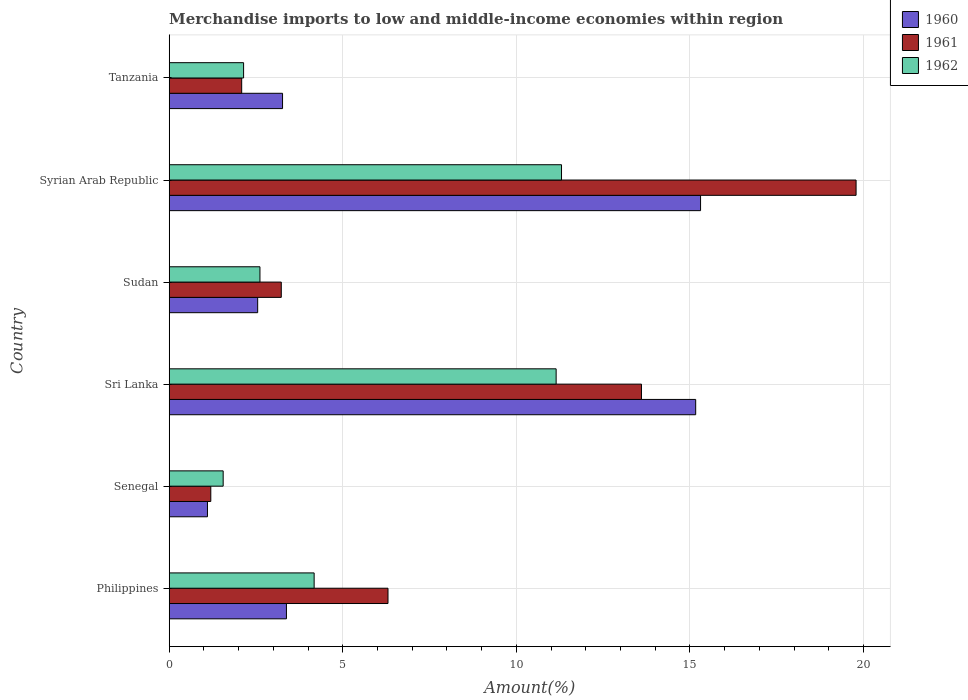Are the number of bars per tick equal to the number of legend labels?
Your answer should be very brief. Yes. What is the label of the 1st group of bars from the top?
Ensure brevity in your answer.  Tanzania. What is the percentage of amount earned from merchandise imports in 1962 in Syrian Arab Republic?
Your answer should be very brief. 11.3. Across all countries, what is the maximum percentage of amount earned from merchandise imports in 1961?
Offer a terse response. 19.79. Across all countries, what is the minimum percentage of amount earned from merchandise imports in 1962?
Give a very brief answer. 1.55. In which country was the percentage of amount earned from merchandise imports in 1960 maximum?
Your response must be concise. Syrian Arab Republic. In which country was the percentage of amount earned from merchandise imports in 1962 minimum?
Offer a very short reply. Senegal. What is the total percentage of amount earned from merchandise imports in 1960 in the graph?
Provide a succinct answer. 40.77. What is the difference between the percentage of amount earned from merchandise imports in 1960 in Philippines and that in Senegal?
Your answer should be compact. 2.28. What is the difference between the percentage of amount earned from merchandise imports in 1960 in Sudan and the percentage of amount earned from merchandise imports in 1962 in Tanzania?
Ensure brevity in your answer.  0.41. What is the average percentage of amount earned from merchandise imports in 1960 per country?
Offer a very short reply. 6.79. What is the difference between the percentage of amount earned from merchandise imports in 1962 and percentage of amount earned from merchandise imports in 1961 in Sri Lanka?
Offer a terse response. -2.46. What is the ratio of the percentage of amount earned from merchandise imports in 1961 in Sudan to that in Tanzania?
Your response must be concise. 1.55. Is the percentage of amount earned from merchandise imports in 1962 in Philippines less than that in Senegal?
Offer a very short reply. No. What is the difference between the highest and the second highest percentage of amount earned from merchandise imports in 1962?
Your answer should be very brief. 0.16. What is the difference between the highest and the lowest percentage of amount earned from merchandise imports in 1962?
Provide a short and direct response. 9.75. Is the sum of the percentage of amount earned from merchandise imports in 1962 in Senegal and Sudan greater than the maximum percentage of amount earned from merchandise imports in 1961 across all countries?
Your answer should be compact. No. How many bars are there?
Give a very brief answer. 18. Are all the bars in the graph horizontal?
Offer a terse response. Yes. Does the graph contain any zero values?
Give a very brief answer. No. What is the title of the graph?
Your answer should be compact. Merchandise imports to low and middle-income economies within region. Does "1985" appear as one of the legend labels in the graph?
Ensure brevity in your answer.  No. What is the label or title of the X-axis?
Keep it short and to the point. Amount(%). What is the Amount(%) of 1960 in Philippines?
Your answer should be compact. 3.38. What is the Amount(%) of 1961 in Philippines?
Ensure brevity in your answer.  6.3. What is the Amount(%) in 1962 in Philippines?
Provide a succinct answer. 4.18. What is the Amount(%) in 1960 in Senegal?
Your answer should be very brief. 1.1. What is the Amount(%) of 1961 in Senegal?
Your answer should be compact. 1.2. What is the Amount(%) in 1962 in Senegal?
Your answer should be compact. 1.55. What is the Amount(%) in 1960 in Sri Lanka?
Give a very brief answer. 15.17. What is the Amount(%) of 1961 in Sri Lanka?
Keep it short and to the point. 13.6. What is the Amount(%) of 1962 in Sri Lanka?
Provide a short and direct response. 11.15. What is the Amount(%) in 1960 in Sudan?
Keep it short and to the point. 2.55. What is the Amount(%) of 1961 in Sudan?
Make the answer very short. 3.23. What is the Amount(%) in 1962 in Sudan?
Provide a succinct answer. 2.61. What is the Amount(%) of 1960 in Syrian Arab Republic?
Keep it short and to the point. 15.31. What is the Amount(%) in 1961 in Syrian Arab Republic?
Offer a very short reply. 19.79. What is the Amount(%) in 1962 in Syrian Arab Republic?
Ensure brevity in your answer.  11.3. What is the Amount(%) in 1960 in Tanzania?
Offer a very short reply. 3.26. What is the Amount(%) in 1961 in Tanzania?
Your answer should be very brief. 2.09. What is the Amount(%) in 1962 in Tanzania?
Your answer should be compact. 2.14. Across all countries, what is the maximum Amount(%) in 1960?
Provide a short and direct response. 15.31. Across all countries, what is the maximum Amount(%) of 1961?
Your answer should be compact. 19.79. Across all countries, what is the maximum Amount(%) of 1962?
Your answer should be very brief. 11.3. Across all countries, what is the minimum Amount(%) of 1960?
Give a very brief answer. 1.1. Across all countries, what is the minimum Amount(%) in 1961?
Your answer should be very brief. 1.2. Across all countries, what is the minimum Amount(%) of 1962?
Your answer should be very brief. 1.55. What is the total Amount(%) of 1960 in the graph?
Offer a terse response. 40.77. What is the total Amount(%) of 1961 in the graph?
Give a very brief answer. 46.21. What is the total Amount(%) in 1962 in the graph?
Keep it short and to the point. 32.93. What is the difference between the Amount(%) in 1960 in Philippines and that in Senegal?
Give a very brief answer. 2.28. What is the difference between the Amount(%) in 1961 in Philippines and that in Senegal?
Your response must be concise. 5.1. What is the difference between the Amount(%) in 1962 in Philippines and that in Senegal?
Offer a very short reply. 2.62. What is the difference between the Amount(%) of 1960 in Philippines and that in Sri Lanka?
Your response must be concise. -11.79. What is the difference between the Amount(%) of 1961 in Philippines and that in Sri Lanka?
Make the answer very short. -7.3. What is the difference between the Amount(%) of 1962 in Philippines and that in Sri Lanka?
Provide a succinct answer. -6.97. What is the difference between the Amount(%) in 1960 in Philippines and that in Sudan?
Ensure brevity in your answer.  0.83. What is the difference between the Amount(%) of 1961 in Philippines and that in Sudan?
Offer a terse response. 3.07. What is the difference between the Amount(%) in 1962 in Philippines and that in Sudan?
Keep it short and to the point. 1.56. What is the difference between the Amount(%) in 1960 in Philippines and that in Syrian Arab Republic?
Offer a very short reply. -11.93. What is the difference between the Amount(%) of 1961 in Philippines and that in Syrian Arab Republic?
Your response must be concise. -13.48. What is the difference between the Amount(%) in 1962 in Philippines and that in Syrian Arab Republic?
Make the answer very short. -7.13. What is the difference between the Amount(%) in 1960 in Philippines and that in Tanzania?
Make the answer very short. 0.11. What is the difference between the Amount(%) in 1961 in Philippines and that in Tanzania?
Provide a short and direct response. 4.21. What is the difference between the Amount(%) in 1962 in Philippines and that in Tanzania?
Offer a terse response. 2.03. What is the difference between the Amount(%) in 1960 in Senegal and that in Sri Lanka?
Your response must be concise. -14.06. What is the difference between the Amount(%) in 1961 in Senegal and that in Sri Lanka?
Give a very brief answer. -12.41. What is the difference between the Amount(%) in 1962 in Senegal and that in Sri Lanka?
Provide a succinct answer. -9.59. What is the difference between the Amount(%) in 1960 in Senegal and that in Sudan?
Give a very brief answer. -1.45. What is the difference between the Amount(%) in 1961 in Senegal and that in Sudan?
Keep it short and to the point. -2.03. What is the difference between the Amount(%) of 1962 in Senegal and that in Sudan?
Provide a short and direct response. -1.06. What is the difference between the Amount(%) of 1960 in Senegal and that in Syrian Arab Republic?
Ensure brevity in your answer.  -14.2. What is the difference between the Amount(%) of 1961 in Senegal and that in Syrian Arab Republic?
Your response must be concise. -18.59. What is the difference between the Amount(%) in 1962 in Senegal and that in Syrian Arab Republic?
Make the answer very short. -9.75. What is the difference between the Amount(%) in 1960 in Senegal and that in Tanzania?
Offer a very short reply. -2.16. What is the difference between the Amount(%) of 1961 in Senegal and that in Tanzania?
Offer a very short reply. -0.89. What is the difference between the Amount(%) of 1962 in Senegal and that in Tanzania?
Your answer should be very brief. -0.59. What is the difference between the Amount(%) of 1960 in Sri Lanka and that in Sudan?
Your answer should be compact. 12.62. What is the difference between the Amount(%) of 1961 in Sri Lanka and that in Sudan?
Provide a short and direct response. 10.38. What is the difference between the Amount(%) in 1962 in Sri Lanka and that in Sudan?
Your answer should be compact. 8.53. What is the difference between the Amount(%) in 1960 in Sri Lanka and that in Syrian Arab Republic?
Provide a short and direct response. -0.14. What is the difference between the Amount(%) in 1961 in Sri Lanka and that in Syrian Arab Republic?
Provide a succinct answer. -6.18. What is the difference between the Amount(%) in 1962 in Sri Lanka and that in Syrian Arab Republic?
Offer a very short reply. -0.16. What is the difference between the Amount(%) of 1960 in Sri Lanka and that in Tanzania?
Provide a succinct answer. 11.9. What is the difference between the Amount(%) of 1961 in Sri Lanka and that in Tanzania?
Provide a short and direct response. 11.52. What is the difference between the Amount(%) in 1962 in Sri Lanka and that in Tanzania?
Keep it short and to the point. 9. What is the difference between the Amount(%) of 1960 in Sudan and that in Syrian Arab Republic?
Provide a short and direct response. -12.76. What is the difference between the Amount(%) of 1961 in Sudan and that in Syrian Arab Republic?
Your answer should be compact. -16.56. What is the difference between the Amount(%) in 1962 in Sudan and that in Syrian Arab Republic?
Keep it short and to the point. -8.69. What is the difference between the Amount(%) in 1960 in Sudan and that in Tanzania?
Ensure brevity in your answer.  -0.72. What is the difference between the Amount(%) in 1961 in Sudan and that in Tanzania?
Offer a very short reply. 1.14. What is the difference between the Amount(%) of 1962 in Sudan and that in Tanzania?
Keep it short and to the point. 0.47. What is the difference between the Amount(%) of 1960 in Syrian Arab Republic and that in Tanzania?
Ensure brevity in your answer.  12.04. What is the difference between the Amount(%) in 1961 in Syrian Arab Republic and that in Tanzania?
Ensure brevity in your answer.  17.7. What is the difference between the Amount(%) in 1962 in Syrian Arab Republic and that in Tanzania?
Ensure brevity in your answer.  9.16. What is the difference between the Amount(%) in 1960 in Philippines and the Amount(%) in 1961 in Senegal?
Keep it short and to the point. 2.18. What is the difference between the Amount(%) of 1960 in Philippines and the Amount(%) of 1962 in Senegal?
Provide a short and direct response. 1.82. What is the difference between the Amount(%) of 1961 in Philippines and the Amount(%) of 1962 in Senegal?
Your response must be concise. 4.75. What is the difference between the Amount(%) in 1960 in Philippines and the Amount(%) in 1961 in Sri Lanka?
Offer a very short reply. -10.23. What is the difference between the Amount(%) in 1960 in Philippines and the Amount(%) in 1962 in Sri Lanka?
Offer a very short reply. -7.77. What is the difference between the Amount(%) of 1961 in Philippines and the Amount(%) of 1962 in Sri Lanka?
Your response must be concise. -4.84. What is the difference between the Amount(%) of 1960 in Philippines and the Amount(%) of 1961 in Sudan?
Offer a terse response. 0.15. What is the difference between the Amount(%) in 1960 in Philippines and the Amount(%) in 1962 in Sudan?
Your answer should be very brief. 0.76. What is the difference between the Amount(%) of 1961 in Philippines and the Amount(%) of 1962 in Sudan?
Ensure brevity in your answer.  3.69. What is the difference between the Amount(%) of 1960 in Philippines and the Amount(%) of 1961 in Syrian Arab Republic?
Keep it short and to the point. -16.41. What is the difference between the Amount(%) of 1960 in Philippines and the Amount(%) of 1962 in Syrian Arab Republic?
Your answer should be very brief. -7.92. What is the difference between the Amount(%) in 1961 in Philippines and the Amount(%) in 1962 in Syrian Arab Republic?
Provide a short and direct response. -5. What is the difference between the Amount(%) in 1960 in Philippines and the Amount(%) in 1961 in Tanzania?
Offer a very short reply. 1.29. What is the difference between the Amount(%) in 1960 in Philippines and the Amount(%) in 1962 in Tanzania?
Your answer should be very brief. 1.23. What is the difference between the Amount(%) in 1961 in Philippines and the Amount(%) in 1962 in Tanzania?
Your answer should be compact. 4.16. What is the difference between the Amount(%) of 1960 in Senegal and the Amount(%) of 1961 in Sri Lanka?
Ensure brevity in your answer.  -12.5. What is the difference between the Amount(%) in 1960 in Senegal and the Amount(%) in 1962 in Sri Lanka?
Your answer should be compact. -10.04. What is the difference between the Amount(%) of 1961 in Senegal and the Amount(%) of 1962 in Sri Lanka?
Provide a succinct answer. -9.95. What is the difference between the Amount(%) of 1960 in Senegal and the Amount(%) of 1961 in Sudan?
Your answer should be very brief. -2.13. What is the difference between the Amount(%) in 1960 in Senegal and the Amount(%) in 1962 in Sudan?
Offer a terse response. -1.51. What is the difference between the Amount(%) in 1961 in Senegal and the Amount(%) in 1962 in Sudan?
Your answer should be compact. -1.42. What is the difference between the Amount(%) in 1960 in Senegal and the Amount(%) in 1961 in Syrian Arab Republic?
Provide a succinct answer. -18.68. What is the difference between the Amount(%) in 1960 in Senegal and the Amount(%) in 1962 in Syrian Arab Republic?
Provide a succinct answer. -10.2. What is the difference between the Amount(%) in 1961 in Senegal and the Amount(%) in 1962 in Syrian Arab Republic?
Your response must be concise. -10.1. What is the difference between the Amount(%) of 1960 in Senegal and the Amount(%) of 1961 in Tanzania?
Your answer should be compact. -0.99. What is the difference between the Amount(%) in 1960 in Senegal and the Amount(%) in 1962 in Tanzania?
Ensure brevity in your answer.  -1.04. What is the difference between the Amount(%) of 1961 in Senegal and the Amount(%) of 1962 in Tanzania?
Your answer should be very brief. -0.94. What is the difference between the Amount(%) in 1960 in Sri Lanka and the Amount(%) in 1961 in Sudan?
Your answer should be very brief. 11.94. What is the difference between the Amount(%) in 1960 in Sri Lanka and the Amount(%) in 1962 in Sudan?
Your response must be concise. 12.55. What is the difference between the Amount(%) in 1961 in Sri Lanka and the Amount(%) in 1962 in Sudan?
Ensure brevity in your answer.  10.99. What is the difference between the Amount(%) in 1960 in Sri Lanka and the Amount(%) in 1961 in Syrian Arab Republic?
Give a very brief answer. -4.62. What is the difference between the Amount(%) in 1960 in Sri Lanka and the Amount(%) in 1962 in Syrian Arab Republic?
Offer a terse response. 3.87. What is the difference between the Amount(%) in 1961 in Sri Lanka and the Amount(%) in 1962 in Syrian Arab Republic?
Keep it short and to the point. 2.3. What is the difference between the Amount(%) in 1960 in Sri Lanka and the Amount(%) in 1961 in Tanzania?
Provide a short and direct response. 13.08. What is the difference between the Amount(%) in 1960 in Sri Lanka and the Amount(%) in 1962 in Tanzania?
Your response must be concise. 13.02. What is the difference between the Amount(%) of 1961 in Sri Lanka and the Amount(%) of 1962 in Tanzania?
Your answer should be very brief. 11.46. What is the difference between the Amount(%) of 1960 in Sudan and the Amount(%) of 1961 in Syrian Arab Republic?
Your answer should be compact. -17.24. What is the difference between the Amount(%) of 1960 in Sudan and the Amount(%) of 1962 in Syrian Arab Republic?
Offer a very short reply. -8.75. What is the difference between the Amount(%) in 1961 in Sudan and the Amount(%) in 1962 in Syrian Arab Republic?
Your response must be concise. -8.07. What is the difference between the Amount(%) of 1960 in Sudan and the Amount(%) of 1961 in Tanzania?
Provide a succinct answer. 0.46. What is the difference between the Amount(%) in 1960 in Sudan and the Amount(%) in 1962 in Tanzania?
Keep it short and to the point. 0.41. What is the difference between the Amount(%) of 1961 in Sudan and the Amount(%) of 1962 in Tanzania?
Give a very brief answer. 1.09. What is the difference between the Amount(%) of 1960 in Syrian Arab Republic and the Amount(%) of 1961 in Tanzania?
Offer a very short reply. 13.22. What is the difference between the Amount(%) of 1960 in Syrian Arab Republic and the Amount(%) of 1962 in Tanzania?
Ensure brevity in your answer.  13.16. What is the difference between the Amount(%) in 1961 in Syrian Arab Republic and the Amount(%) in 1962 in Tanzania?
Provide a succinct answer. 17.64. What is the average Amount(%) of 1960 per country?
Offer a terse response. 6.79. What is the average Amount(%) of 1961 per country?
Your answer should be compact. 7.7. What is the average Amount(%) of 1962 per country?
Your answer should be compact. 5.49. What is the difference between the Amount(%) of 1960 and Amount(%) of 1961 in Philippines?
Provide a short and direct response. -2.93. What is the difference between the Amount(%) in 1960 and Amount(%) in 1962 in Philippines?
Offer a terse response. -0.8. What is the difference between the Amount(%) of 1961 and Amount(%) of 1962 in Philippines?
Make the answer very short. 2.13. What is the difference between the Amount(%) of 1960 and Amount(%) of 1961 in Senegal?
Your answer should be very brief. -0.1. What is the difference between the Amount(%) of 1960 and Amount(%) of 1962 in Senegal?
Your response must be concise. -0.45. What is the difference between the Amount(%) in 1961 and Amount(%) in 1962 in Senegal?
Your answer should be very brief. -0.36. What is the difference between the Amount(%) of 1960 and Amount(%) of 1961 in Sri Lanka?
Offer a terse response. 1.56. What is the difference between the Amount(%) in 1960 and Amount(%) in 1962 in Sri Lanka?
Provide a short and direct response. 4.02. What is the difference between the Amount(%) of 1961 and Amount(%) of 1962 in Sri Lanka?
Your answer should be very brief. 2.46. What is the difference between the Amount(%) of 1960 and Amount(%) of 1961 in Sudan?
Ensure brevity in your answer.  -0.68. What is the difference between the Amount(%) of 1960 and Amount(%) of 1962 in Sudan?
Your response must be concise. -0.07. What is the difference between the Amount(%) in 1961 and Amount(%) in 1962 in Sudan?
Ensure brevity in your answer.  0.61. What is the difference between the Amount(%) in 1960 and Amount(%) in 1961 in Syrian Arab Republic?
Your answer should be very brief. -4.48. What is the difference between the Amount(%) of 1960 and Amount(%) of 1962 in Syrian Arab Republic?
Your answer should be compact. 4.01. What is the difference between the Amount(%) in 1961 and Amount(%) in 1962 in Syrian Arab Republic?
Ensure brevity in your answer.  8.49. What is the difference between the Amount(%) of 1960 and Amount(%) of 1961 in Tanzania?
Keep it short and to the point. 1.18. What is the difference between the Amount(%) in 1960 and Amount(%) in 1962 in Tanzania?
Provide a succinct answer. 1.12. What is the difference between the Amount(%) of 1961 and Amount(%) of 1962 in Tanzania?
Your response must be concise. -0.05. What is the ratio of the Amount(%) of 1960 in Philippines to that in Senegal?
Offer a terse response. 3.06. What is the ratio of the Amount(%) in 1961 in Philippines to that in Senegal?
Your response must be concise. 5.26. What is the ratio of the Amount(%) of 1962 in Philippines to that in Senegal?
Offer a terse response. 2.69. What is the ratio of the Amount(%) in 1960 in Philippines to that in Sri Lanka?
Keep it short and to the point. 0.22. What is the ratio of the Amount(%) in 1961 in Philippines to that in Sri Lanka?
Make the answer very short. 0.46. What is the ratio of the Amount(%) in 1962 in Philippines to that in Sri Lanka?
Give a very brief answer. 0.37. What is the ratio of the Amount(%) of 1960 in Philippines to that in Sudan?
Ensure brevity in your answer.  1.33. What is the ratio of the Amount(%) in 1961 in Philippines to that in Sudan?
Your answer should be very brief. 1.95. What is the ratio of the Amount(%) in 1962 in Philippines to that in Sudan?
Give a very brief answer. 1.6. What is the ratio of the Amount(%) in 1960 in Philippines to that in Syrian Arab Republic?
Offer a very short reply. 0.22. What is the ratio of the Amount(%) in 1961 in Philippines to that in Syrian Arab Republic?
Ensure brevity in your answer.  0.32. What is the ratio of the Amount(%) of 1962 in Philippines to that in Syrian Arab Republic?
Your answer should be very brief. 0.37. What is the ratio of the Amount(%) in 1960 in Philippines to that in Tanzania?
Provide a succinct answer. 1.03. What is the ratio of the Amount(%) in 1961 in Philippines to that in Tanzania?
Give a very brief answer. 3.02. What is the ratio of the Amount(%) of 1962 in Philippines to that in Tanzania?
Offer a terse response. 1.95. What is the ratio of the Amount(%) of 1960 in Senegal to that in Sri Lanka?
Ensure brevity in your answer.  0.07. What is the ratio of the Amount(%) of 1961 in Senegal to that in Sri Lanka?
Keep it short and to the point. 0.09. What is the ratio of the Amount(%) in 1962 in Senegal to that in Sri Lanka?
Your answer should be very brief. 0.14. What is the ratio of the Amount(%) of 1960 in Senegal to that in Sudan?
Ensure brevity in your answer.  0.43. What is the ratio of the Amount(%) of 1961 in Senegal to that in Sudan?
Offer a terse response. 0.37. What is the ratio of the Amount(%) of 1962 in Senegal to that in Sudan?
Your response must be concise. 0.59. What is the ratio of the Amount(%) in 1960 in Senegal to that in Syrian Arab Republic?
Your response must be concise. 0.07. What is the ratio of the Amount(%) in 1961 in Senegal to that in Syrian Arab Republic?
Your answer should be compact. 0.06. What is the ratio of the Amount(%) of 1962 in Senegal to that in Syrian Arab Republic?
Make the answer very short. 0.14. What is the ratio of the Amount(%) of 1960 in Senegal to that in Tanzania?
Offer a terse response. 0.34. What is the ratio of the Amount(%) of 1961 in Senegal to that in Tanzania?
Make the answer very short. 0.57. What is the ratio of the Amount(%) in 1962 in Senegal to that in Tanzania?
Your answer should be compact. 0.73. What is the ratio of the Amount(%) of 1960 in Sri Lanka to that in Sudan?
Ensure brevity in your answer.  5.95. What is the ratio of the Amount(%) of 1961 in Sri Lanka to that in Sudan?
Provide a succinct answer. 4.21. What is the ratio of the Amount(%) in 1962 in Sri Lanka to that in Sudan?
Your answer should be compact. 4.26. What is the ratio of the Amount(%) in 1960 in Sri Lanka to that in Syrian Arab Republic?
Keep it short and to the point. 0.99. What is the ratio of the Amount(%) of 1961 in Sri Lanka to that in Syrian Arab Republic?
Provide a succinct answer. 0.69. What is the ratio of the Amount(%) in 1962 in Sri Lanka to that in Syrian Arab Republic?
Your answer should be compact. 0.99. What is the ratio of the Amount(%) in 1960 in Sri Lanka to that in Tanzania?
Offer a terse response. 4.65. What is the ratio of the Amount(%) of 1961 in Sri Lanka to that in Tanzania?
Make the answer very short. 6.51. What is the ratio of the Amount(%) of 1962 in Sri Lanka to that in Tanzania?
Ensure brevity in your answer.  5.2. What is the ratio of the Amount(%) in 1960 in Sudan to that in Syrian Arab Republic?
Provide a succinct answer. 0.17. What is the ratio of the Amount(%) in 1961 in Sudan to that in Syrian Arab Republic?
Provide a succinct answer. 0.16. What is the ratio of the Amount(%) of 1962 in Sudan to that in Syrian Arab Republic?
Your answer should be very brief. 0.23. What is the ratio of the Amount(%) in 1960 in Sudan to that in Tanzania?
Give a very brief answer. 0.78. What is the ratio of the Amount(%) of 1961 in Sudan to that in Tanzania?
Your answer should be compact. 1.55. What is the ratio of the Amount(%) in 1962 in Sudan to that in Tanzania?
Ensure brevity in your answer.  1.22. What is the ratio of the Amount(%) in 1960 in Syrian Arab Republic to that in Tanzania?
Your answer should be compact. 4.69. What is the ratio of the Amount(%) of 1961 in Syrian Arab Republic to that in Tanzania?
Provide a succinct answer. 9.48. What is the ratio of the Amount(%) of 1962 in Syrian Arab Republic to that in Tanzania?
Give a very brief answer. 5.27. What is the difference between the highest and the second highest Amount(%) of 1960?
Offer a very short reply. 0.14. What is the difference between the highest and the second highest Amount(%) in 1961?
Offer a very short reply. 6.18. What is the difference between the highest and the second highest Amount(%) of 1962?
Give a very brief answer. 0.16. What is the difference between the highest and the lowest Amount(%) in 1960?
Your answer should be very brief. 14.2. What is the difference between the highest and the lowest Amount(%) of 1961?
Make the answer very short. 18.59. What is the difference between the highest and the lowest Amount(%) in 1962?
Ensure brevity in your answer.  9.75. 